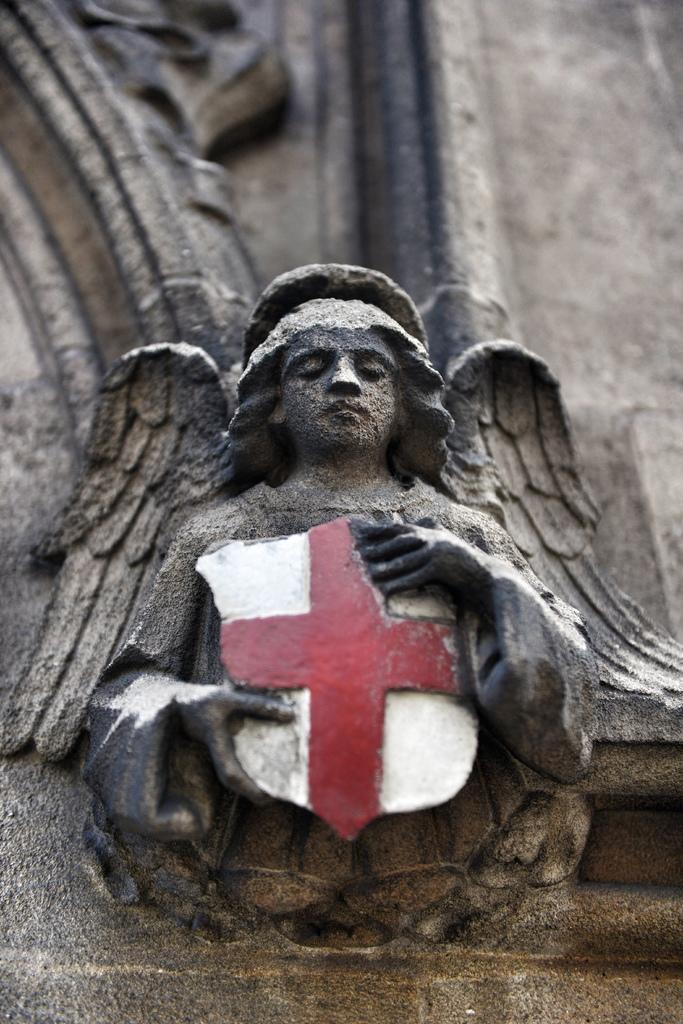Describe this image in one or two sentences. In this image I can see the statue of the person and the statue is holding the cross symbol. 